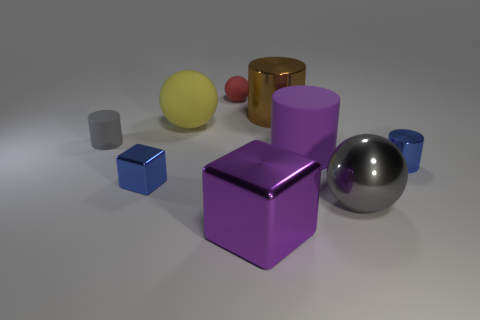There is a thing that is the same color as the tiny metal cylinder; what is its shape?
Make the answer very short. Cube. How many other objects are there of the same size as the red rubber thing?
Your answer should be compact. 3. The blue thing in front of the tiny blue metal object to the right of the metallic object on the left side of the small rubber ball is made of what material?
Offer a terse response. Metal. How many balls are yellow rubber objects or tiny gray objects?
Provide a short and direct response. 1. Is there any other thing that is the same shape as the big purple matte object?
Ensure brevity in your answer.  Yes. Are there more tiny red things behind the brown shiny thing than small gray objects right of the big rubber cylinder?
Provide a short and direct response. Yes. What number of small matte cylinders are on the right side of the tiny metallic thing that is right of the yellow rubber object?
Give a very brief answer. 0. How many objects are yellow spheres or tiny metal blocks?
Provide a succinct answer. 2. Is the brown metallic object the same shape as the small red matte object?
Provide a succinct answer. No. What is the big yellow thing made of?
Keep it short and to the point. Rubber. 